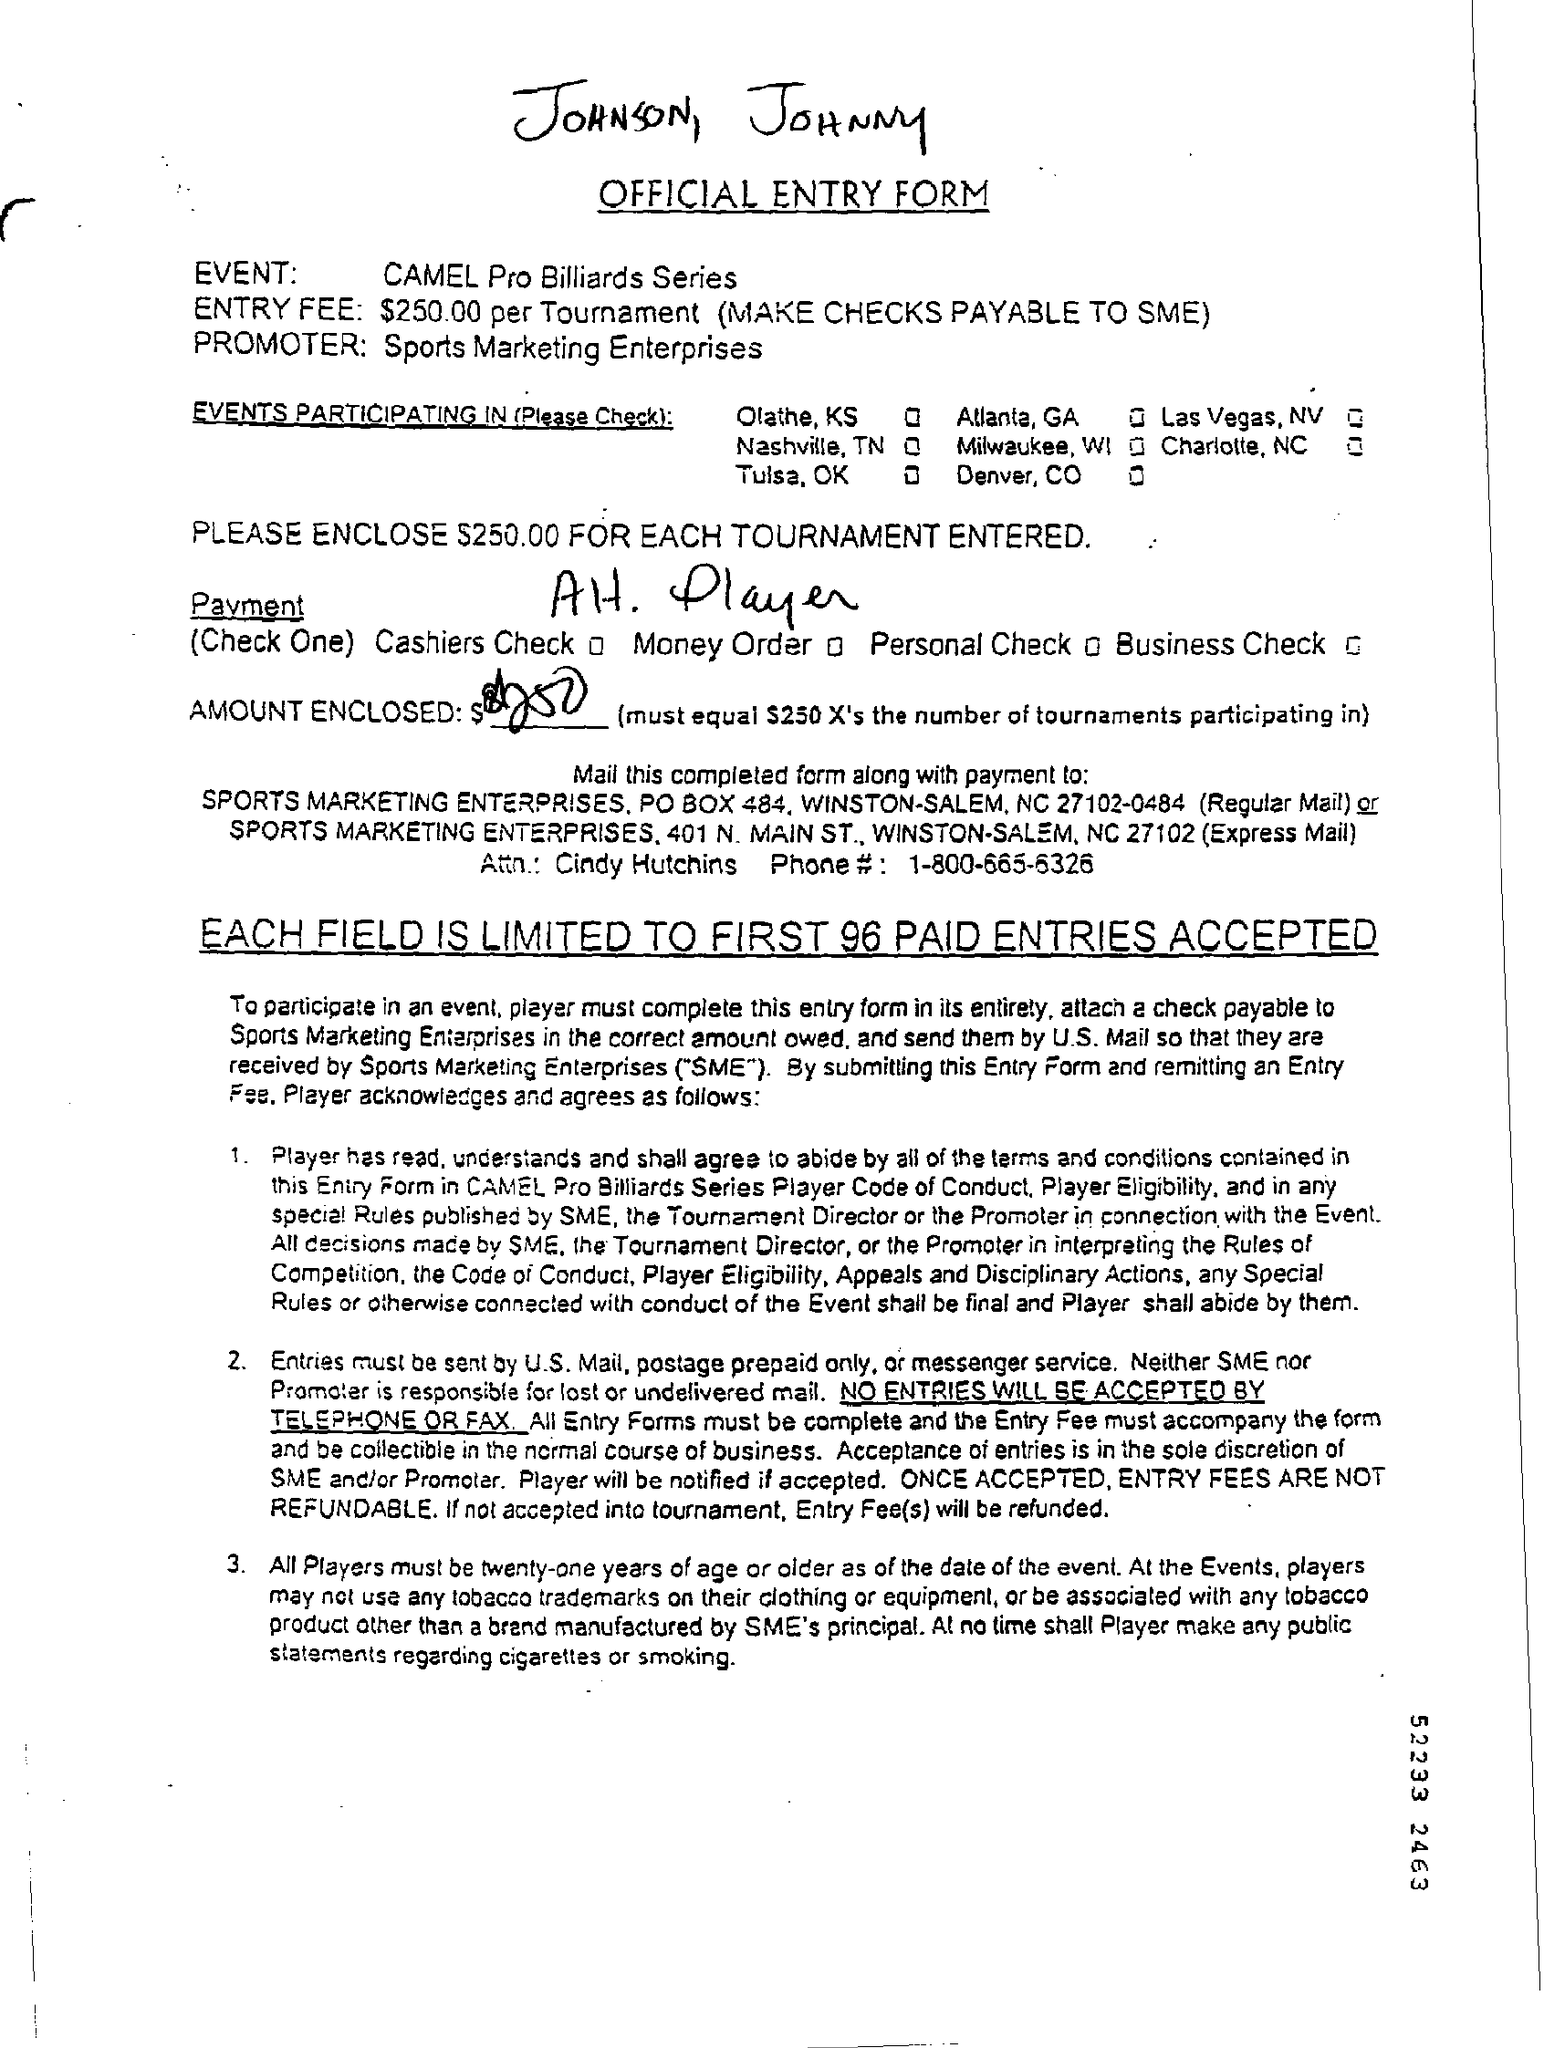Specify some key components in this picture. Each field is limited to accepting a certain number of paid entries, with 96 as the maximum. The age of the players participating in the event must be 21 years or older as of the date of the event. 